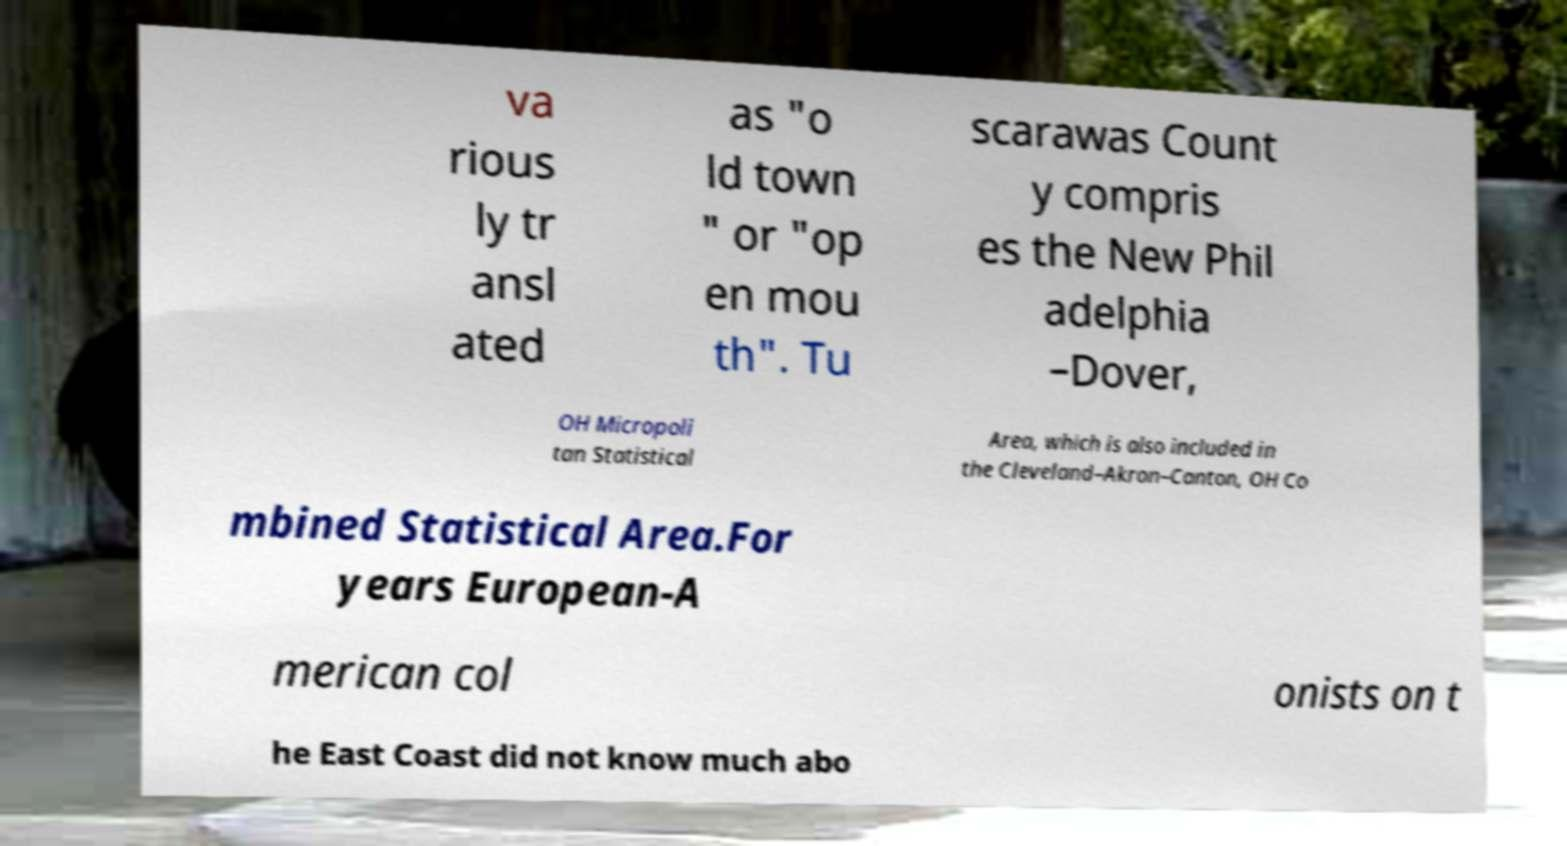What messages or text are displayed in this image? I need them in a readable, typed format. va rious ly tr ansl ated as "o ld town " or "op en mou th". Tu scarawas Count y compris es the New Phil adelphia –Dover, OH Micropoli tan Statistical Area, which is also included in the Cleveland–Akron–Canton, OH Co mbined Statistical Area.For years European-A merican col onists on t he East Coast did not know much abo 